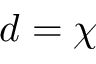Convert formula to latex. <formula><loc_0><loc_0><loc_500><loc_500>d = \chi</formula> 